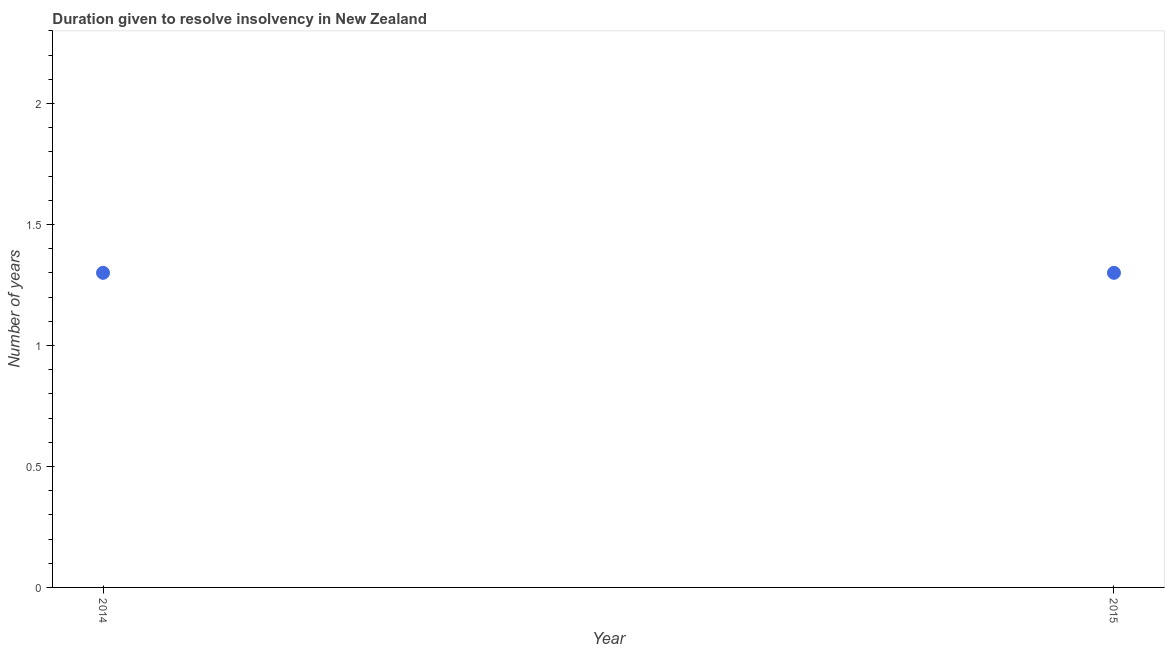Across all years, what is the maximum number of years to resolve insolvency?
Keep it short and to the point. 1.3. Across all years, what is the minimum number of years to resolve insolvency?
Provide a succinct answer. 1.3. In which year was the number of years to resolve insolvency minimum?
Make the answer very short. 2014. What is the difference between the number of years to resolve insolvency in 2014 and 2015?
Your answer should be very brief. 0. In how many years, is the number of years to resolve insolvency greater than 1.8 ?
Provide a succinct answer. 0. What is the ratio of the number of years to resolve insolvency in 2014 to that in 2015?
Your response must be concise. 1. Is the number of years to resolve insolvency in 2014 less than that in 2015?
Ensure brevity in your answer.  No. Does the number of years to resolve insolvency monotonically increase over the years?
Offer a terse response. No. What is the difference between two consecutive major ticks on the Y-axis?
Offer a very short reply. 0.5. Are the values on the major ticks of Y-axis written in scientific E-notation?
Provide a short and direct response. No. Does the graph contain grids?
Provide a succinct answer. No. What is the title of the graph?
Your answer should be compact. Duration given to resolve insolvency in New Zealand. What is the label or title of the X-axis?
Ensure brevity in your answer.  Year. What is the label or title of the Y-axis?
Your answer should be compact. Number of years. What is the Number of years in 2014?
Your response must be concise. 1.3. What is the Number of years in 2015?
Ensure brevity in your answer.  1.3. What is the difference between the Number of years in 2014 and 2015?
Give a very brief answer. 0. 